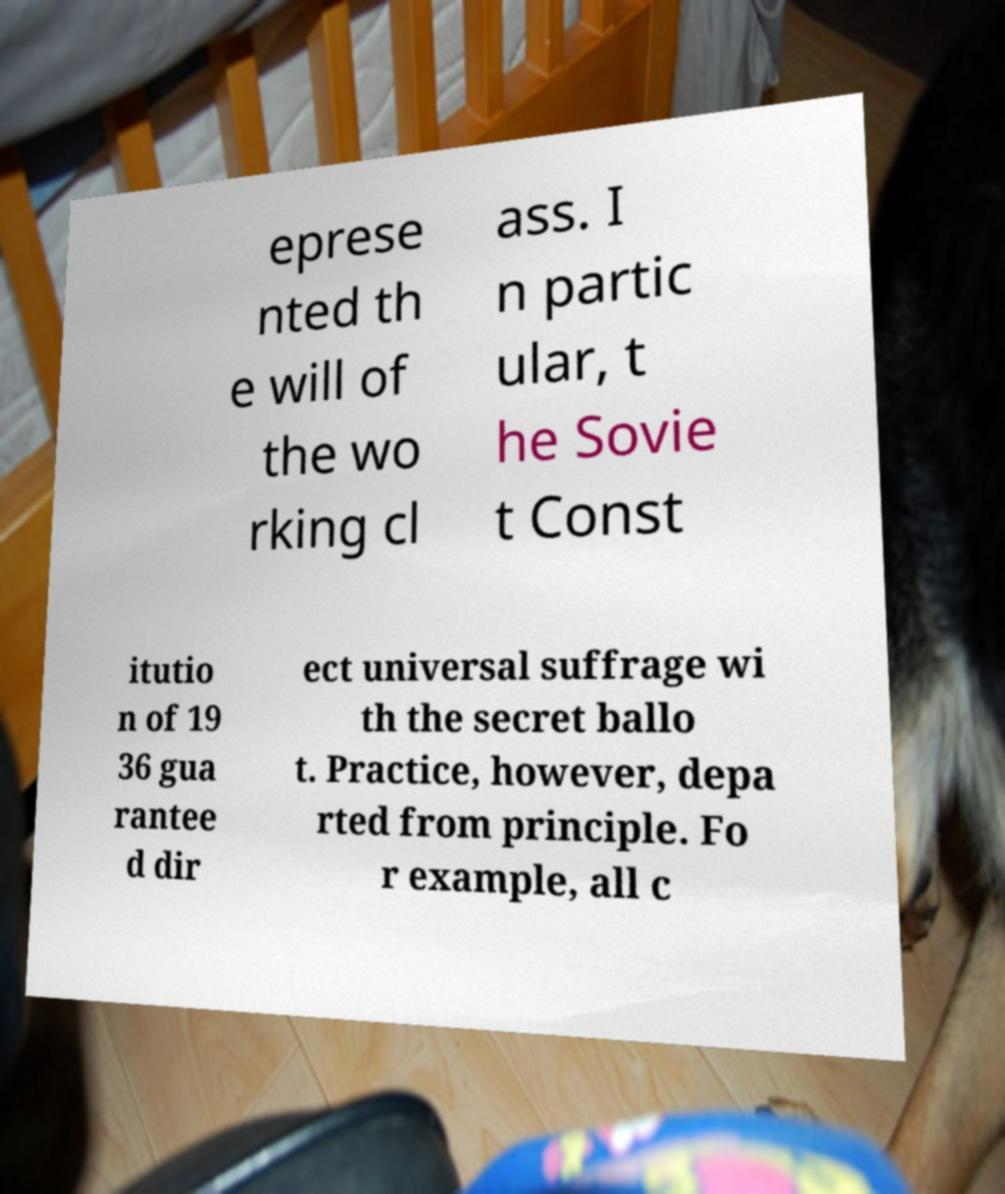For documentation purposes, I need the text within this image transcribed. Could you provide that? eprese nted th e will of the wo rking cl ass. I n partic ular, t he Sovie t Const itutio n of 19 36 gua rantee d dir ect universal suffrage wi th the secret ballo t. Practice, however, depa rted from principle. Fo r example, all c 